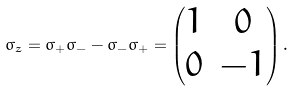Convert formula to latex. <formula><loc_0><loc_0><loc_500><loc_500>\sigma _ { z } = \sigma _ { + } \sigma _ { - } - \sigma _ { - } \sigma _ { + } = \begin{pmatrix} 1 & 0 \\ 0 & - 1 \end{pmatrix} .</formula> 